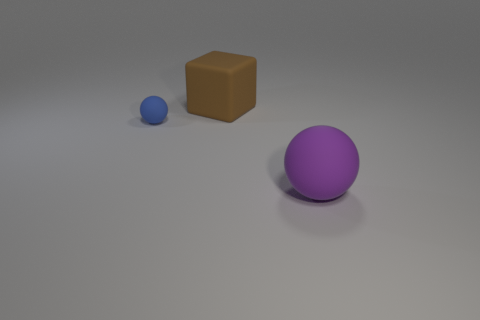Add 2 blue matte objects. How many objects exist? 5 Subtract all blocks. How many objects are left? 2 Add 1 brown rubber cubes. How many brown rubber cubes exist? 2 Subtract 0 purple blocks. How many objects are left? 3 Subtract all small cyan shiny cubes. Subtract all large balls. How many objects are left? 2 Add 3 cubes. How many cubes are left? 4 